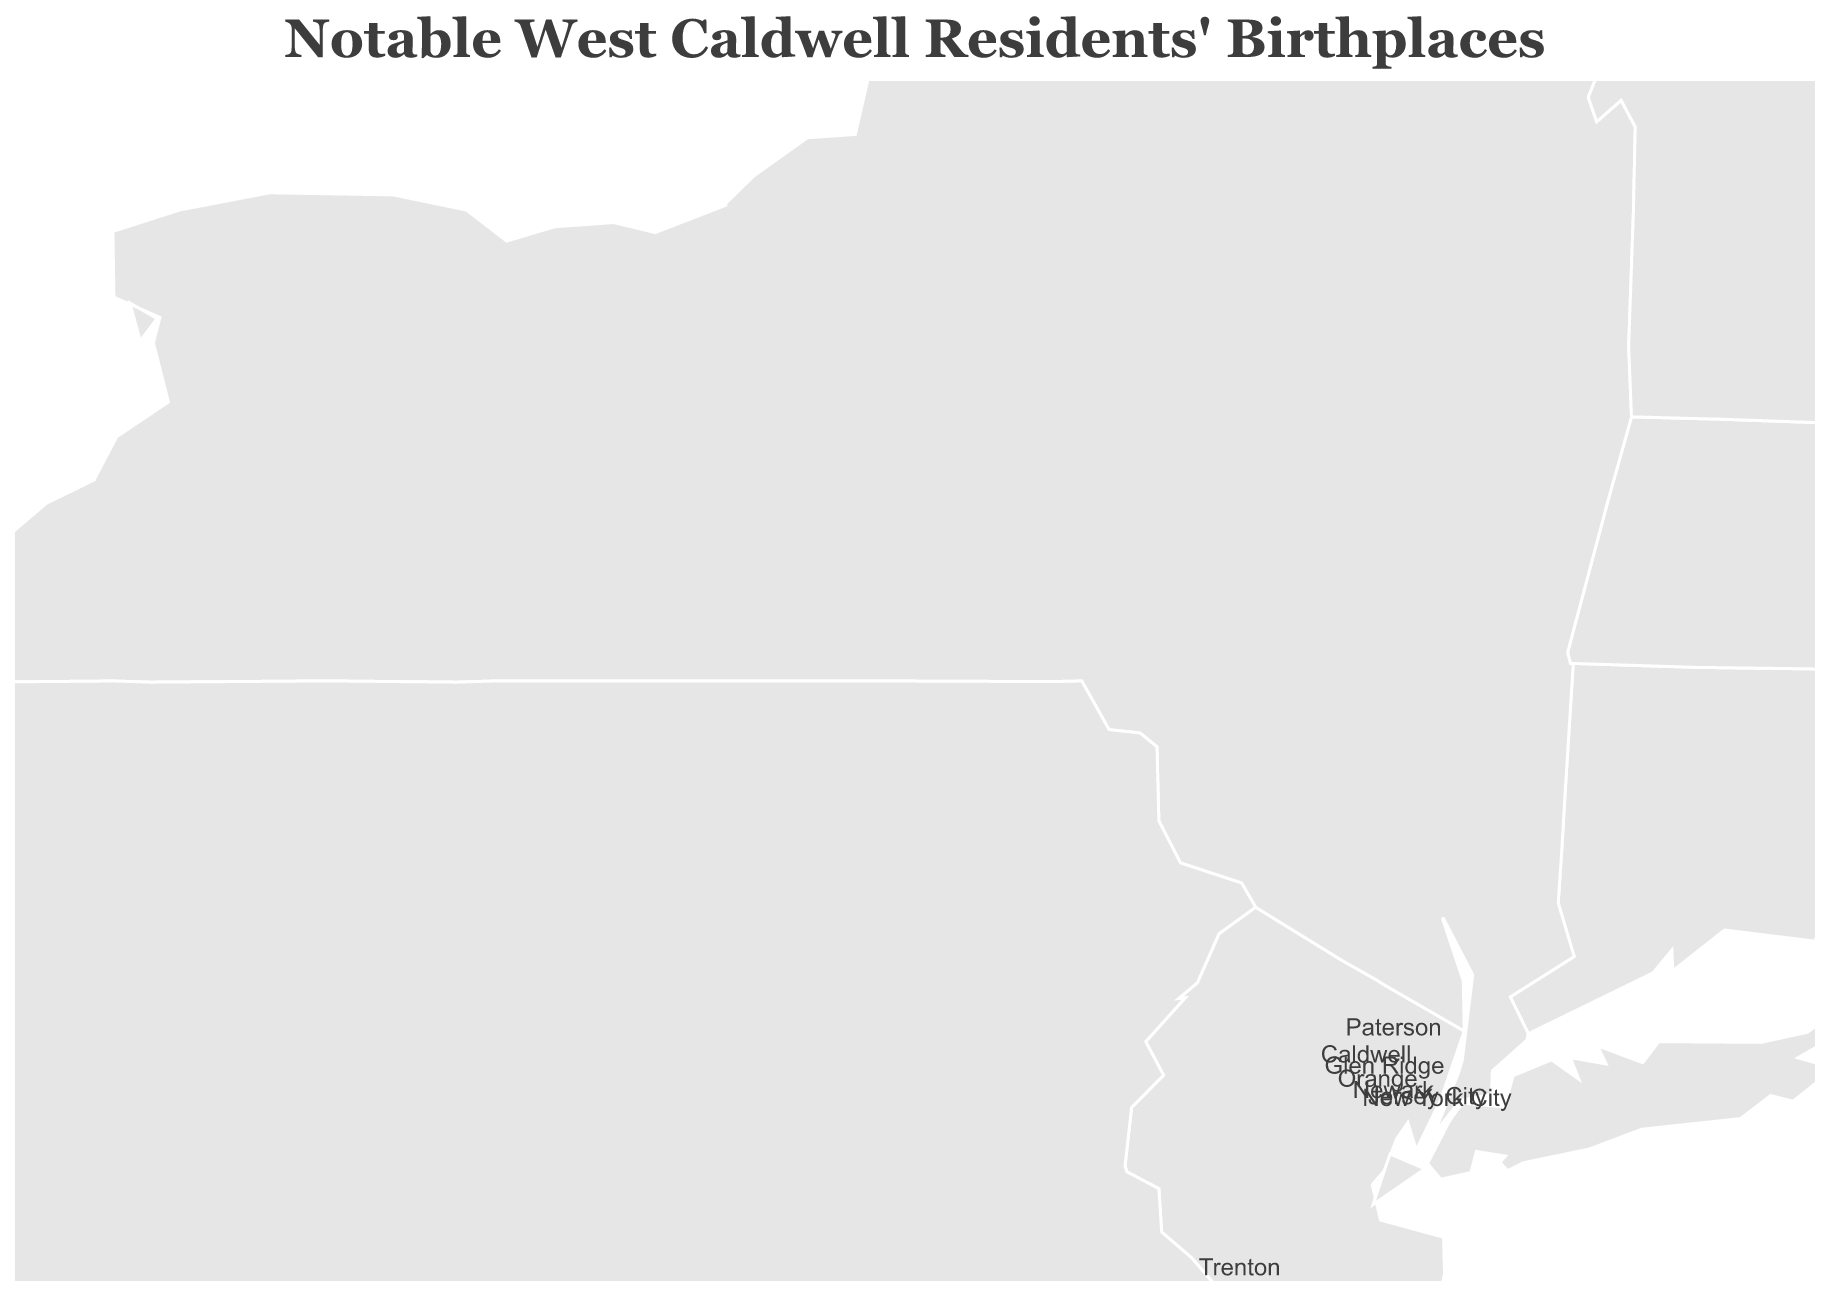What's the title of the plot? The title is displayed prominently at the top of the plot and generally provides a summary of the data being represented.
Answer: Notable West Caldwell Residents' Birthplaces How many notable West Caldwell residents in the plot were born in New Jersey? By observing the data points labeled with their respective birthplaces within the geographic boundaries of New Jersey, we count them. The birthplaces within New Jersey are Caldwell, Orange, Newark, Paterson, Trenton, Jersey City, and Glen Ridge.
Answer: 7 Which birthplace is the farthest from Caldwell, New Jersey? Caldwell, New Jersey is approximately located at coordinates (40.8387, -74.2768). To find the farthest birthplace, we compare the one with the least similar coordinates. Culdaff, Ireland (55.2833, -7.1667) is the farthest.
Answer: Culdaff, Ireland Which two notable residents were born the closest to each other? By comparing the provided birthplaces' coordinates, we analyze the distances between each pair. The pair from Newark and Paterson are the closest due to their close geographic proximity.
Answer: Stephen Crane (Newark) and Edwin Stern (Paterson) How does the birthplace of Buzz Aldrin compare to the birthplace of Grover Cleveland in terms of latitude? To compare their latitudes, we observe that Buzz Aldrin was born in Glen Ridge with a latitude of 40.8062, and Grover Cleveland was born in Caldwell with a latitude of 40.8387. Buzz Aldrin's birthplace is slightly south of Grover Cleveland's birthplace.
Answer: Buzz Aldrin's birthplace is south of Grover Cleveland's birthplace What distinguishes Edwin Stern's birthplace on the plot? To determine what distinguishes Edwin Stern's birthplace, we look to its coordinates. Edwin Stern was born in Paterson, one of the points among those clustered within a region of New Jersey, particularly northern New Jersey.
Answer: In Paterson, within northern New Jersey Which birthplace is located at the greatest longitude to the west? By comparing the longitudes of all the birthplaces, Milan, Ohio with coordinates (41.2975, -82.6055) stands out as the westernmost point.
Answer: Milan, Ohio What is the approximate latitude range covered by the birthplaces of notable West Caldwell residents? The northernmost point is Culdaff, Ireland at 55.2833 while the southernmost point is Trenton at 40.2206. The approximate latitude range is 55.2833 - 40.2206.
Answer: Approximately 15.063 